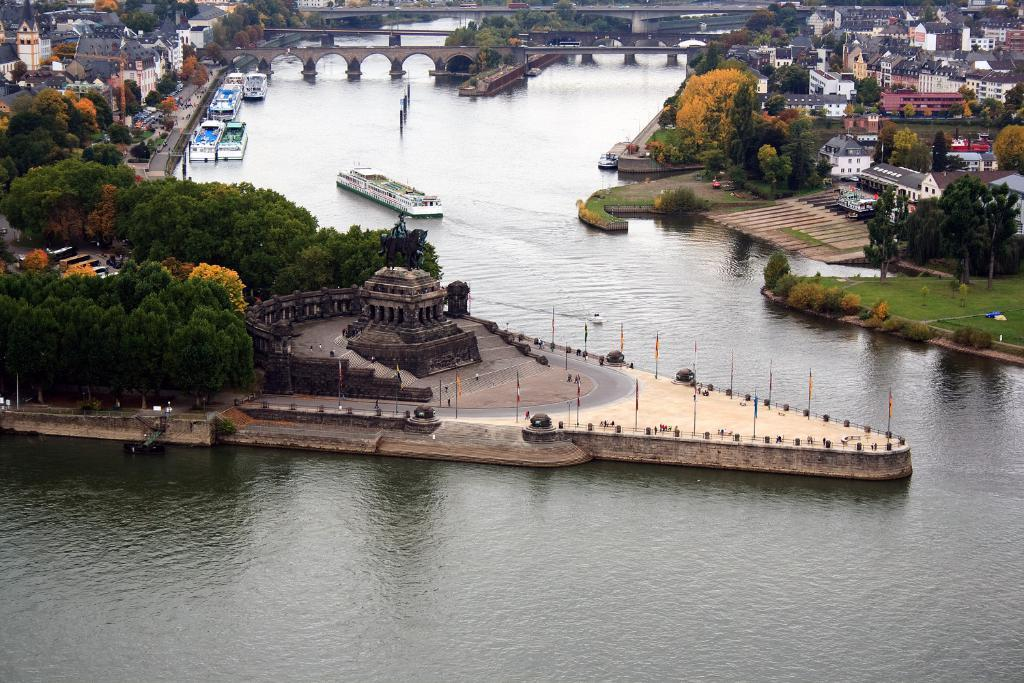What type of view is shown in the image? The image is an aerial view of a city. What structures can be seen in the image? There are buildings, bridges, and ships in the image. What natural elements are present in the image? There are trees, plants, grass, and a water body in the image. Are there any symbols or markers visible in the image? Yes, there are flags in the image. Can you see a duck biting a flag in the image? No, there is no duck or any biting action involving a flag in the image. 